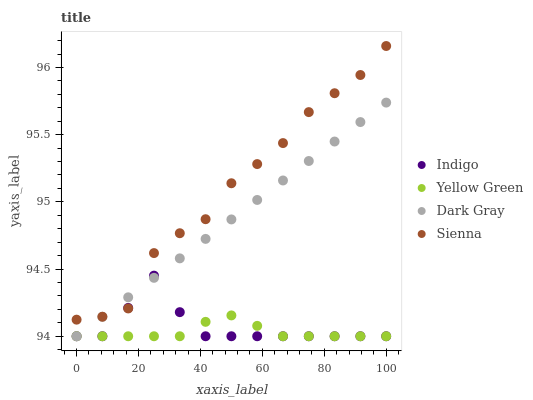Does Yellow Green have the minimum area under the curve?
Answer yes or no. Yes. Does Sienna have the maximum area under the curve?
Answer yes or no. Yes. Does Indigo have the minimum area under the curve?
Answer yes or no. No. Does Indigo have the maximum area under the curve?
Answer yes or no. No. Is Dark Gray the smoothest?
Answer yes or no. Yes. Is Sienna the roughest?
Answer yes or no. Yes. Is Indigo the smoothest?
Answer yes or no. No. Is Indigo the roughest?
Answer yes or no. No. Does Dark Gray have the lowest value?
Answer yes or no. Yes. Does Sienna have the lowest value?
Answer yes or no. No. Does Sienna have the highest value?
Answer yes or no. Yes. Does Indigo have the highest value?
Answer yes or no. No. Is Yellow Green less than Sienna?
Answer yes or no. Yes. Is Sienna greater than Yellow Green?
Answer yes or no. Yes. Does Yellow Green intersect Indigo?
Answer yes or no. Yes. Is Yellow Green less than Indigo?
Answer yes or no. No. Is Yellow Green greater than Indigo?
Answer yes or no. No. Does Yellow Green intersect Sienna?
Answer yes or no. No. 